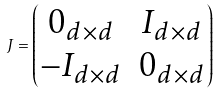<formula> <loc_0><loc_0><loc_500><loc_500>J = \begin{pmatrix} 0 _ { d \times d } & I _ { d \times d } \\ - I _ { d \times d } & 0 _ { d \times d } \end{pmatrix}</formula> 